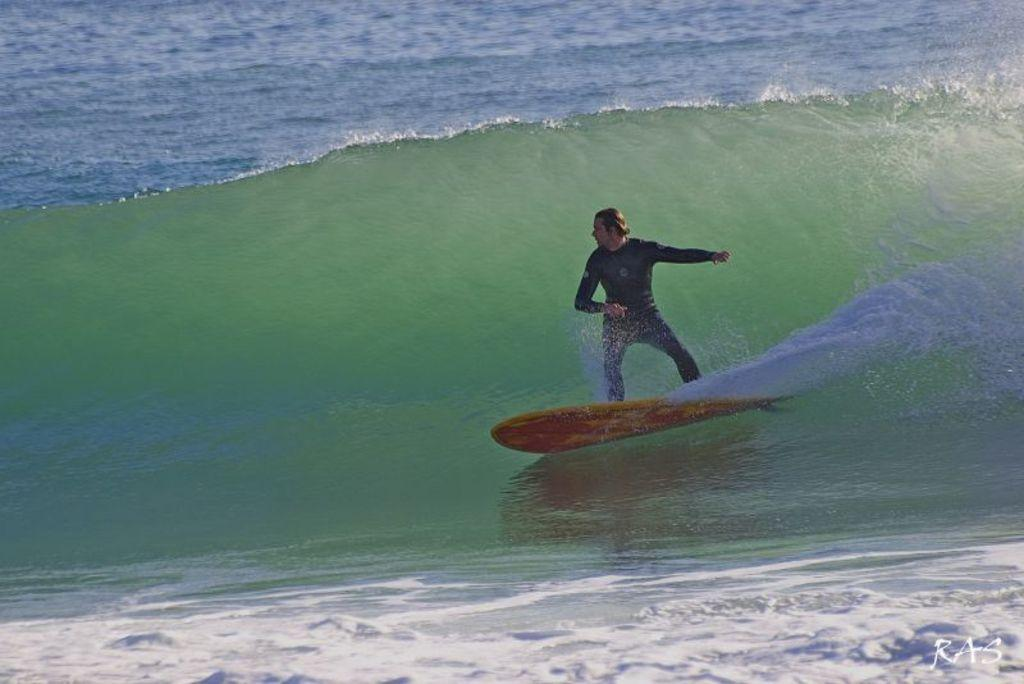What is the person in the image holding? The person is holding a camera. What activity is the person engaged in? The person is taking a picture of a building. Can you describe the location of the person in the image? The person is standing near a building. What type of pen is the person using to write on the building? There is no pen present in the image, and the person is not writing on the building; they are taking a picture of it. 